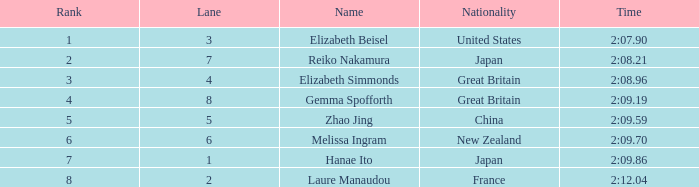What is the highest standing of laure manaudou? 8.0. 